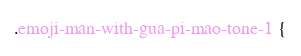<code> <loc_0><loc_0><loc_500><loc_500><_CSS_>.emoji-man-with-gua-pi-mao-tone-1 {</code> 